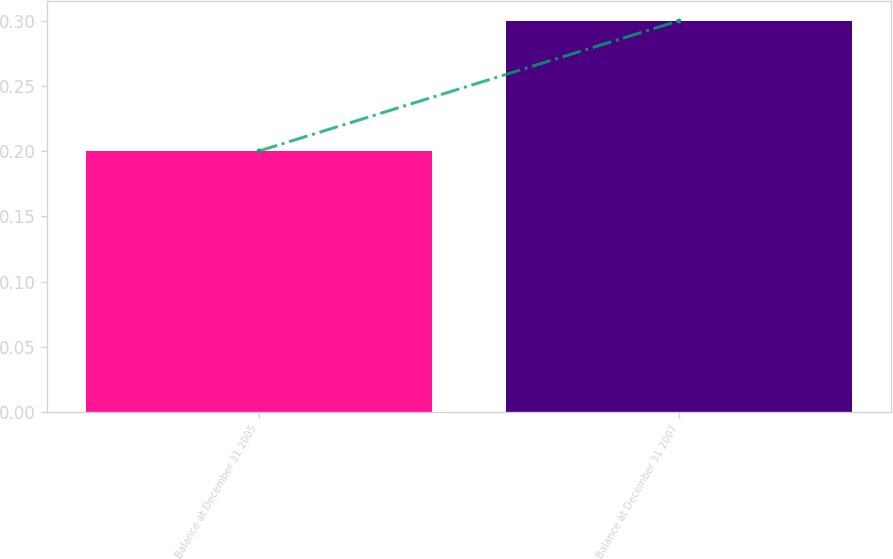Convert chart. <chart><loc_0><loc_0><loc_500><loc_500><bar_chart><fcel>Balance at December 31 2005<fcel>Balance at December 31 2007<nl><fcel>0.2<fcel>0.3<nl></chart> 